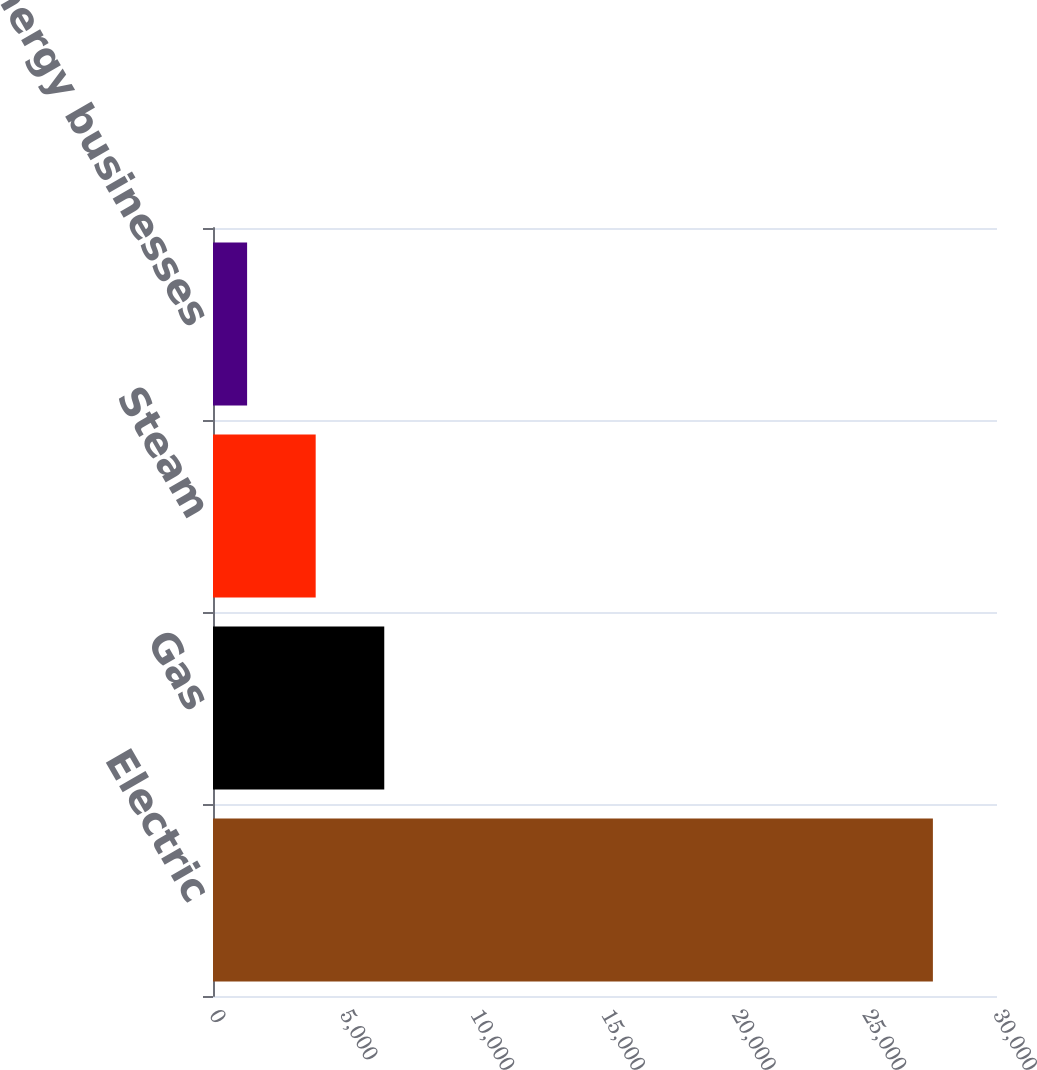Convert chart to OTSL. <chart><loc_0><loc_0><loc_500><loc_500><bar_chart><fcel>Electric<fcel>Gas<fcel>Steam<fcel>Competitive energy businesses<nl><fcel>27547<fcel>6553.4<fcel>3929.2<fcel>1305<nl></chart> 